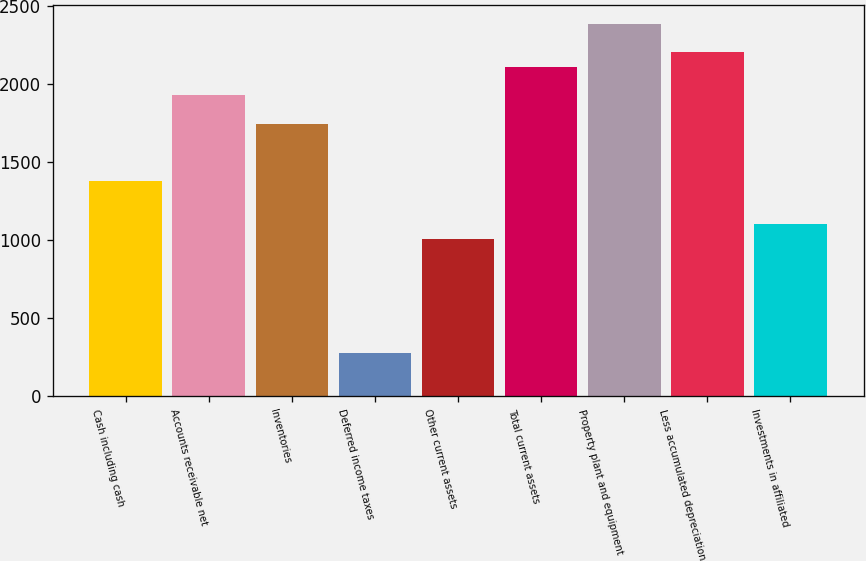<chart> <loc_0><loc_0><loc_500><loc_500><bar_chart><fcel>Cash including cash<fcel>Accounts receivable net<fcel>Inventories<fcel>Deferred income taxes<fcel>Other current assets<fcel>Total current assets<fcel>Property plant and equipment<fcel>Less accumulated depreciation<fcel>Investments in affiliated<nl><fcel>1377.05<fcel>1927.67<fcel>1744.13<fcel>275.81<fcel>1009.97<fcel>2111.21<fcel>2386.52<fcel>2202.98<fcel>1101.74<nl></chart> 